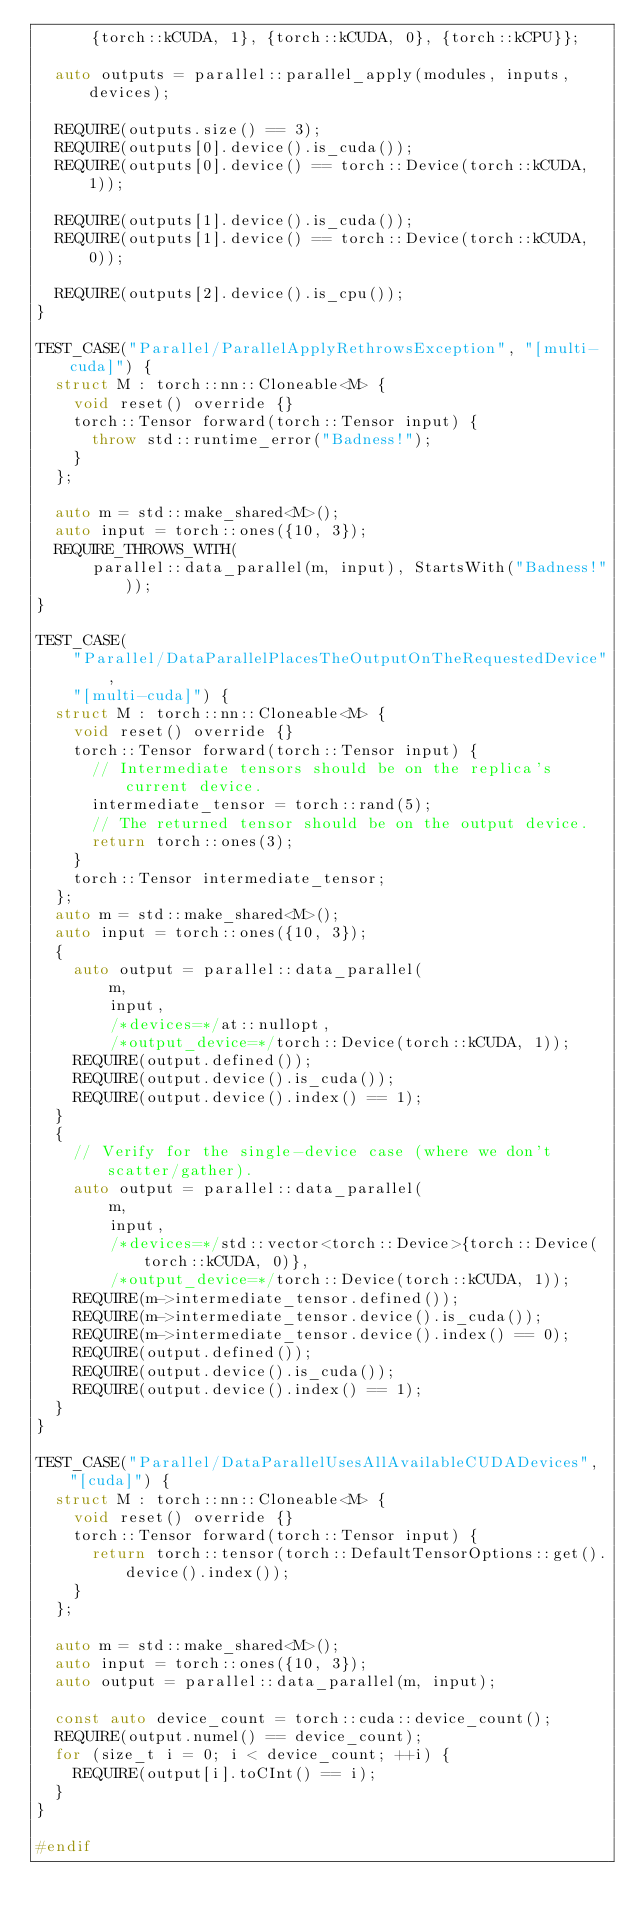<code> <loc_0><loc_0><loc_500><loc_500><_C++_>      {torch::kCUDA, 1}, {torch::kCUDA, 0}, {torch::kCPU}};

  auto outputs = parallel::parallel_apply(modules, inputs, devices);

  REQUIRE(outputs.size() == 3);
  REQUIRE(outputs[0].device().is_cuda());
  REQUIRE(outputs[0].device() == torch::Device(torch::kCUDA, 1));

  REQUIRE(outputs[1].device().is_cuda());
  REQUIRE(outputs[1].device() == torch::Device(torch::kCUDA, 0));

  REQUIRE(outputs[2].device().is_cpu());
}

TEST_CASE("Parallel/ParallelApplyRethrowsException", "[multi-cuda]") {
  struct M : torch::nn::Cloneable<M> {
    void reset() override {}
    torch::Tensor forward(torch::Tensor input) {
      throw std::runtime_error("Badness!");
    }
  };

  auto m = std::make_shared<M>();
  auto input = torch::ones({10, 3});
  REQUIRE_THROWS_WITH(
      parallel::data_parallel(m, input), StartsWith("Badness!"));
}

TEST_CASE(
    "Parallel/DataParallelPlacesTheOutputOnTheRequestedDevice",
    "[multi-cuda]") {
  struct M : torch::nn::Cloneable<M> {
    void reset() override {}
    torch::Tensor forward(torch::Tensor input) {
      // Intermediate tensors should be on the replica's current device.
      intermediate_tensor = torch::rand(5);
      // The returned tensor should be on the output device.
      return torch::ones(3);
    }
    torch::Tensor intermediate_tensor;
  };
  auto m = std::make_shared<M>();
  auto input = torch::ones({10, 3});
  {
    auto output = parallel::data_parallel(
        m,
        input,
        /*devices=*/at::nullopt,
        /*output_device=*/torch::Device(torch::kCUDA, 1));
    REQUIRE(output.defined());
    REQUIRE(output.device().is_cuda());
    REQUIRE(output.device().index() == 1);
  }
  {
    // Verify for the single-device case (where we don't scatter/gather).
    auto output = parallel::data_parallel(
        m,
        input,
        /*devices=*/std::vector<torch::Device>{torch::Device(torch::kCUDA, 0)},
        /*output_device=*/torch::Device(torch::kCUDA, 1));
    REQUIRE(m->intermediate_tensor.defined());
    REQUIRE(m->intermediate_tensor.device().is_cuda());
    REQUIRE(m->intermediate_tensor.device().index() == 0);
    REQUIRE(output.defined());
    REQUIRE(output.device().is_cuda());
    REQUIRE(output.device().index() == 1);
  }
}

TEST_CASE("Parallel/DataParallelUsesAllAvailableCUDADevices", "[cuda]") {
  struct M : torch::nn::Cloneable<M> {
    void reset() override {}
    torch::Tensor forward(torch::Tensor input) {
      return torch::tensor(torch::DefaultTensorOptions::get().device().index());
    }
  };

  auto m = std::make_shared<M>();
  auto input = torch::ones({10, 3});
  auto output = parallel::data_parallel(m, input);

  const auto device_count = torch::cuda::device_count();
  REQUIRE(output.numel() == device_count);
  for (size_t i = 0; i < device_count; ++i) {
    REQUIRE(output[i].toCInt() == i);
  }
}

#endif
</code> 